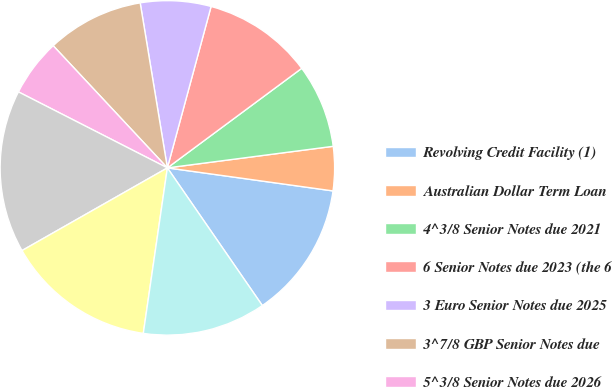<chart> <loc_0><loc_0><loc_500><loc_500><pie_chart><fcel>Revolving Credit Facility (1)<fcel>Australian Dollar Term Loan<fcel>4^3/8 Senior Notes due 2021<fcel>6 Senior Notes due 2023 (the 6<fcel>3 Euro Senior Notes due 2025<fcel>3^7/8 GBP Senior Notes due<fcel>5^3/8 Senior Notes due 2026<fcel>4^7/8 Senior Notes due 2027<fcel>5^1/4 Senior Notes due 2028<fcel>Real Estate Mortgages Capital<nl><fcel>13.19%<fcel>4.26%<fcel>8.09%<fcel>10.64%<fcel>6.81%<fcel>9.36%<fcel>5.53%<fcel>15.74%<fcel>14.47%<fcel>11.91%<nl></chart> 